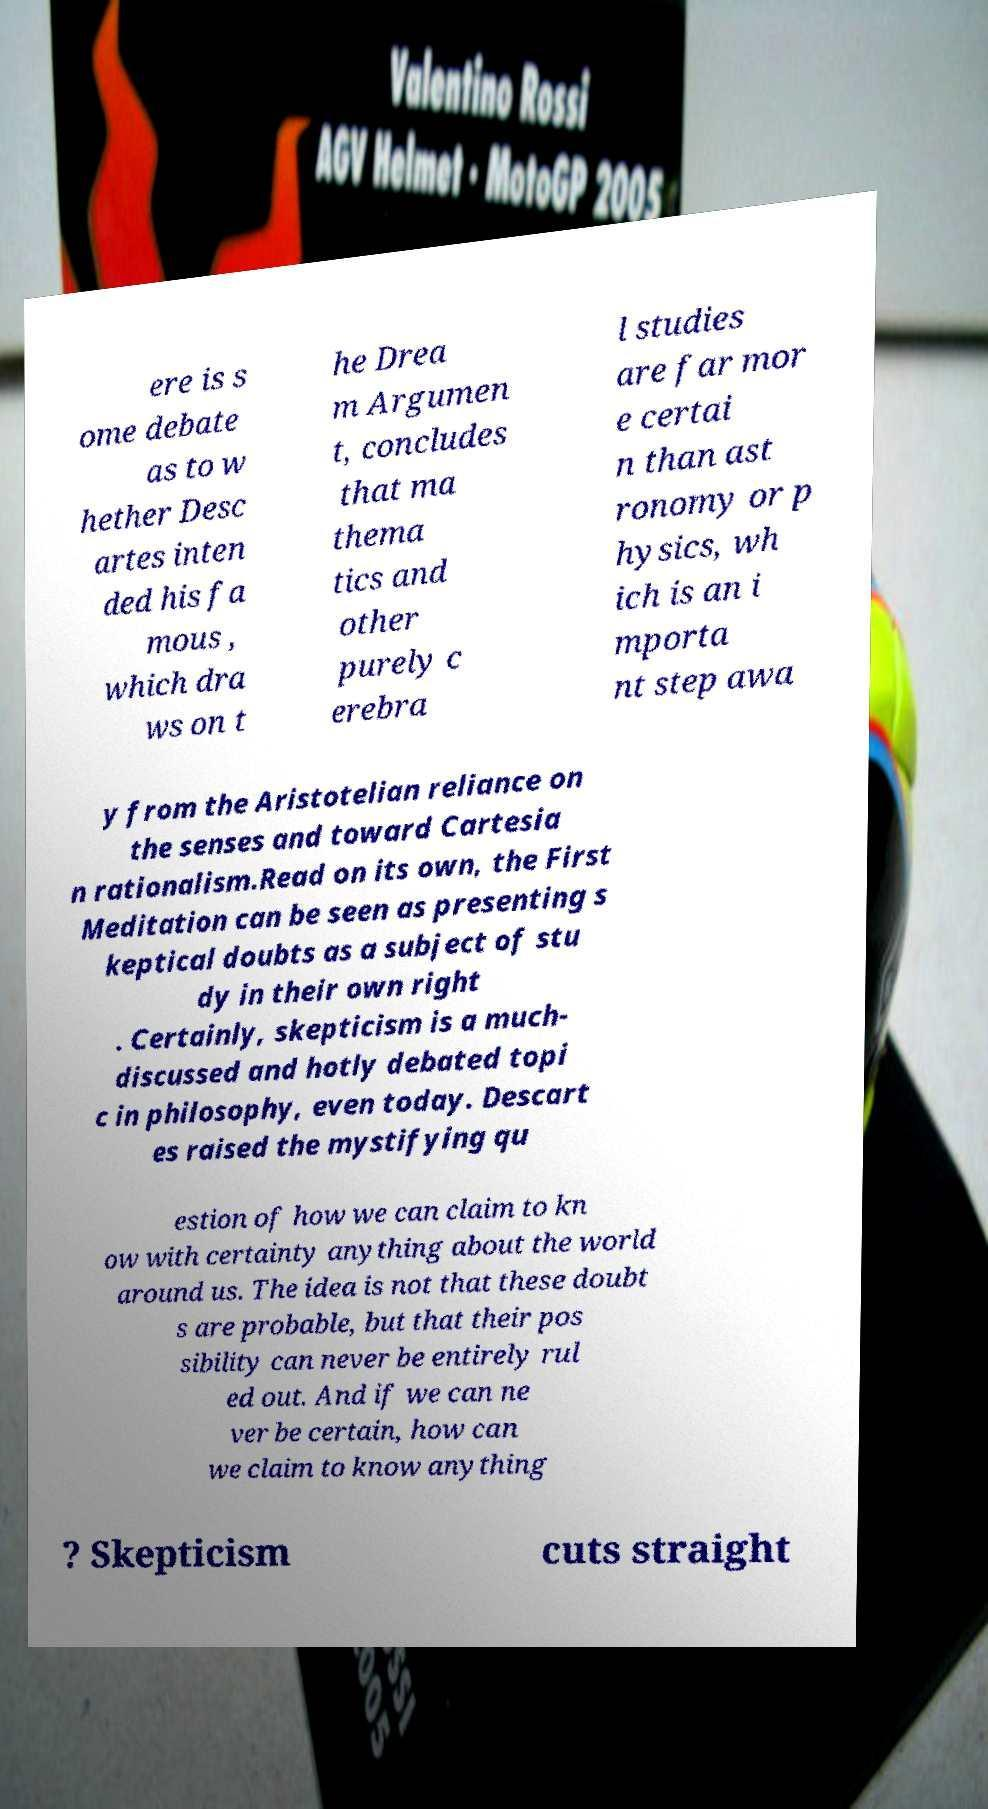Please read and relay the text visible in this image. What does it say? ere is s ome debate as to w hether Desc artes inten ded his fa mous , which dra ws on t he Drea m Argumen t, concludes that ma thema tics and other purely c erebra l studies are far mor e certai n than ast ronomy or p hysics, wh ich is an i mporta nt step awa y from the Aristotelian reliance on the senses and toward Cartesia n rationalism.Read on its own, the First Meditation can be seen as presenting s keptical doubts as a subject of stu dy in their own right . Certainly, skepticism is a much- discussed and hotly debated topi c in philosophy, even today. Descart es raised the mystifying qu estion of how we can claim to kn ow with certainty anything about the world around us. The idea is not that these doubt s are probable, but that their pos sibility can never be entirely rul ed out. And if we can ne ver be certain, how can we claim to know anything ? Skepticism cuts straight 